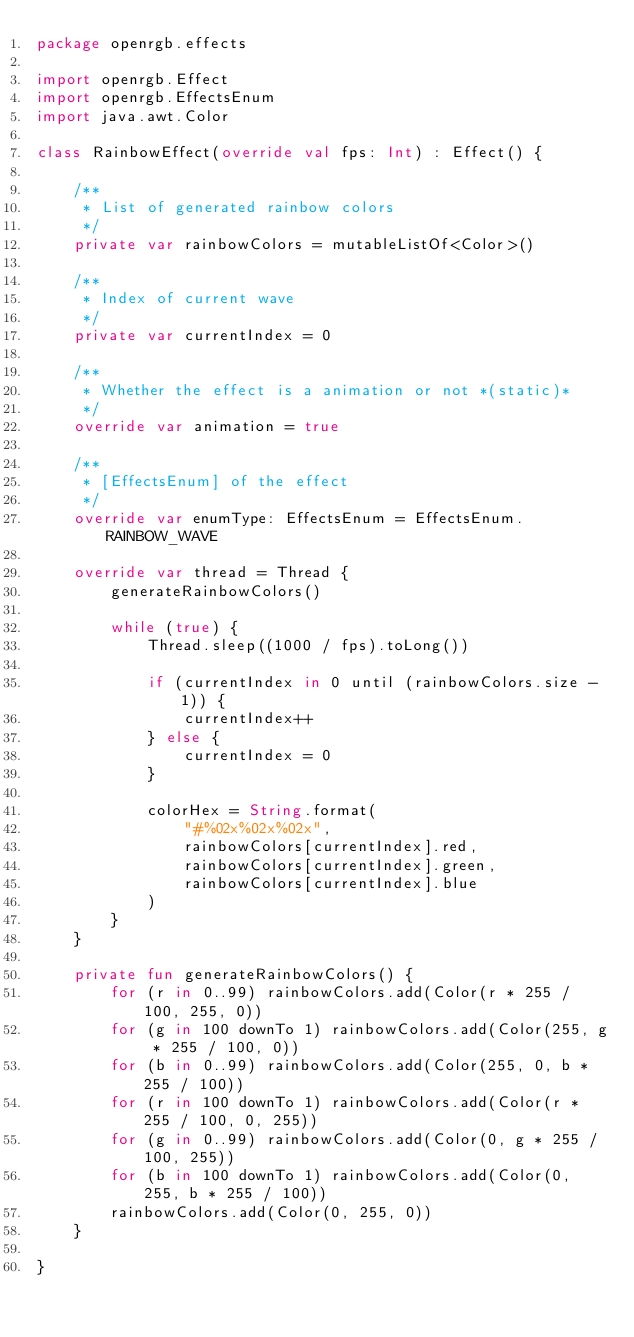Convert code to text. <code><loc_0><loc_0><loc_500><loc_500><_Kotlin_>package openrgb.effects

import openrgb.Effect
import openrgb.EffectsEnum
import java.awt.Color

class RainbowEffect(override val fps: Int) : Effect() {

    /**
     * List of generated rainbow colors
     */
    private var rainbowColors = mutableListOf<Color>()

    /**
     * Index of current wave
     */
    private var currentIndex = 0

    /**
     * Whether the effect is a animation or not *(static)*
     */
    override var animation = true

    /**
     * [EffectsEnum] of the effect
     */
    override var enumType: EffectsEnum = EffectsEnum.RAINBOW_WAVE

    override var thread = Thread {
        generateRainbowColors()

        while (true) {
            Thread.sleep((1000 / fps).toLong())

            if (currentIndex in 0 until (rainbowColors.size - 1)) {
                currentIndex++
            } else {
                currentIndex = 0
            }

            colorHex = String.format(
                "#%02x%02x%02x",
                rainbowColors[currentIndex].red,
                rainbowColors[currentIndex].green,
                rainbowColors[currentIndex].blue
            )
        }
    }

    private fun generateRainbowColors() {
        for (r in 0..99) rainbowColors.add(Color(r * 255 / 100, 255, 0))
        for (g in 100 downTo 1) rainbowColors.add(Color(255, g * 255 / 100, 0))
        for (b in 0..99) rainbowColors.add(Color(255, 0, b * 255 / 100))
        for (r in 100 downTo 1) rainbowColors.add(Color(r * 255 / 100, 0, 255))
        for (g in 0..99) rainbowColors.add(Color(0, g * 255 / 100, 255))
        for (b in 100 downTo 1) rainbowColors.add(Color(0, 255, b * 255 / 100))
        rainbowColors.add(Color(0, 255, 0))
    }

}</code> 